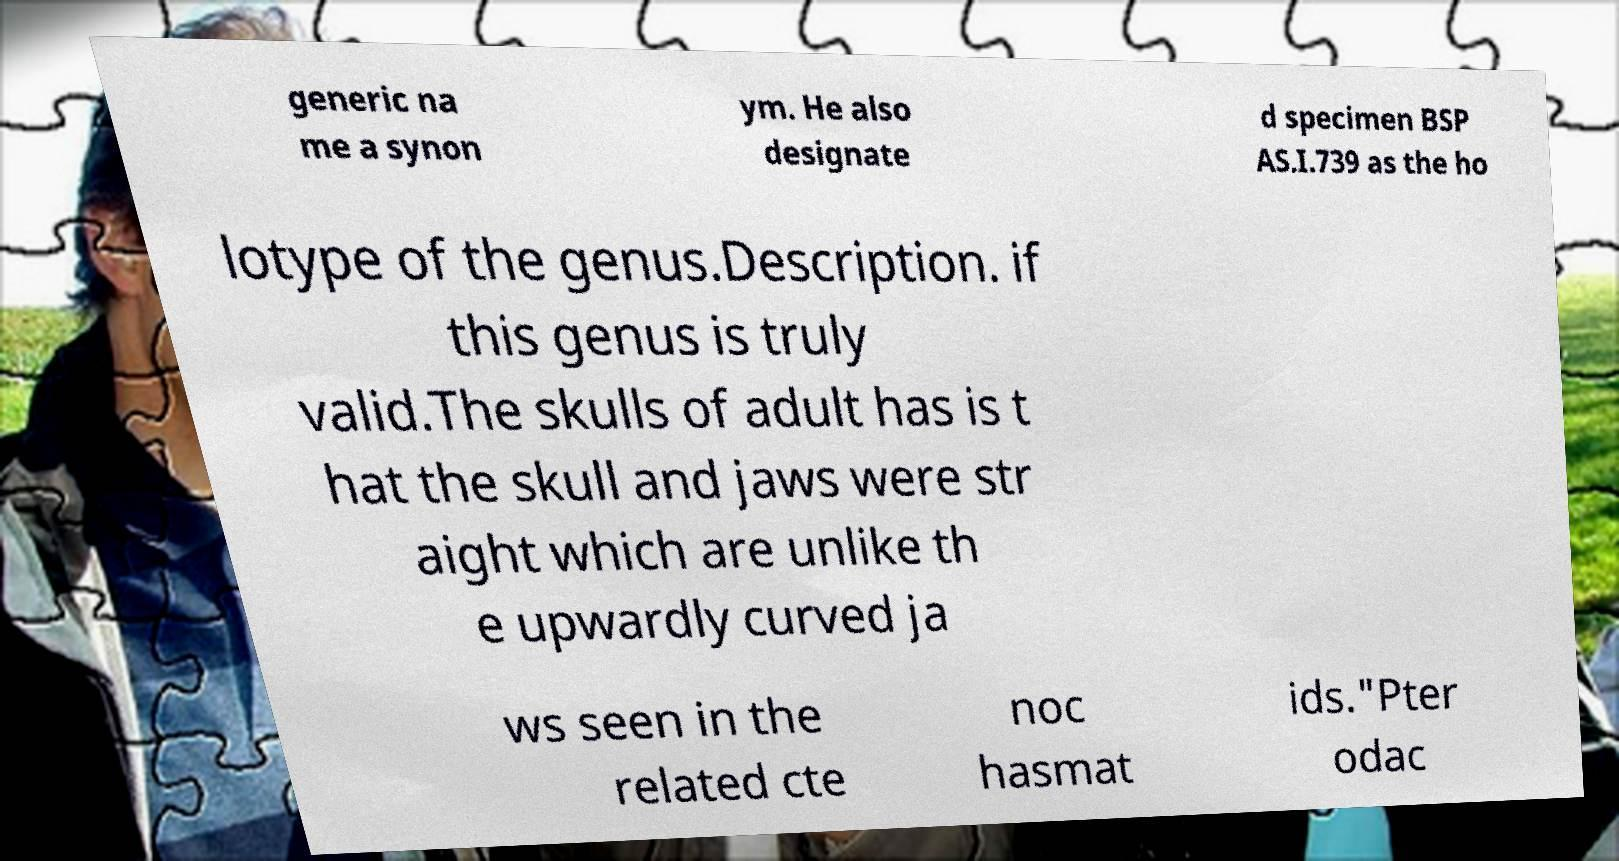Can you accurately transcribe the text from the provided image for me? generic na me a synon ym. He also designate d specimen BSP AS.I.739 as the ho lotype of the genus.Description. if this genus is truly valid.The skulls of adult has is t hat the skull and jaws were str aight which are unlike th e upwardly curved ja ws seen in the related cte noc hasmat ids."Pter odac 